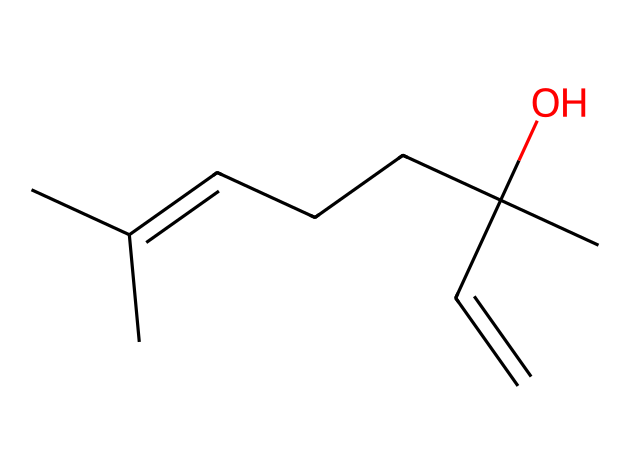What is the molecular formula of linalool? The molecular formula can be derived from the SMILES representation by counting the number of each type of atom present. From the SMILES, there are 10 carbon (C) atoms, 18 hydrogen (H) atoms, and 1 oxygen (O) atom. Therefore, the molecular formula is C10H18O.
Answer: C10H18O How many double bonds are present in the structure? By analyzing the SMILES representation, we can identify the double bonds by looking for the '=' symbol. In this case, there is one '=' indicating one double bond in the chemical structure.
Answer: 1 What functional group is indicated in this chemical structure? Within the SMILES, the 'O' at the end represents a hydroxyl group (–OH), which indicates the presence of an alcohol functional group in the structure.
Answer: alcohol What type of isomerism can linalool exhibit? The presence of a double bond in linalool allows for geometric isomerism (cis/trans isomerism) since the groups attached to the carbons around the double bond can be configured differently.
Answer: geometric How many chiral centers does linalool have? To determine the chiral centers, we look for carbon atoms that are bonded to four different substituents. In analyzing the structure from the SMILES, there are two carbon atoms that meet this criterion, indicating two chiral centers.
Answer: 2 Is linalool saturated or unsaturated? The presence of double bonds typically characterizes a compound as unsaturated. Since linalool contains one double bond, it does not have the maximum number of hydrogen atoms per carbon atom, classifying it as an unsaturated compound.
Answer: unsaturated 